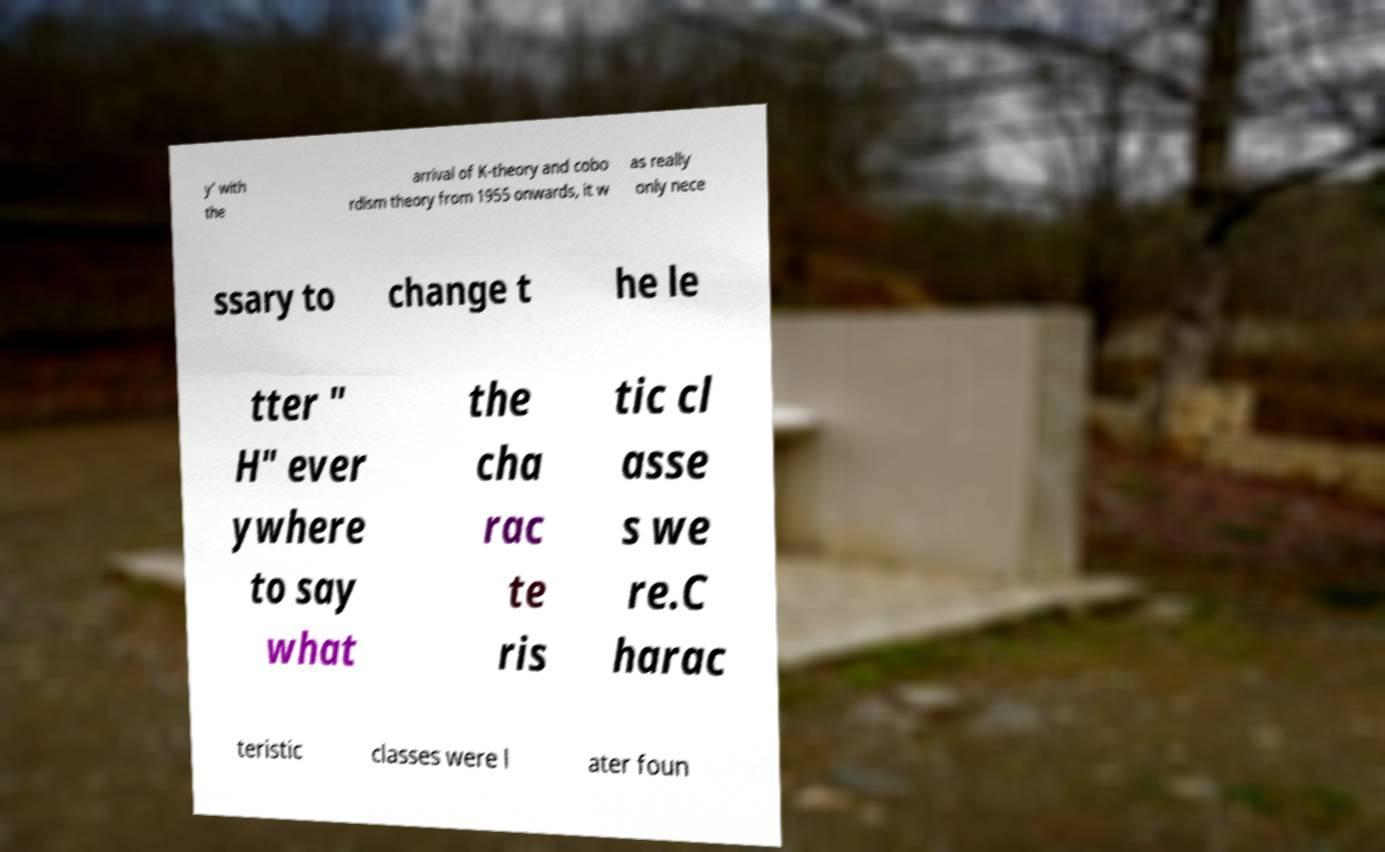Can you accurately transcribe the text from the provided image for me? y' with the arrival of K-theory and cobo rdism theory from 1955 onwards, it w as really only nece ssary to change t he le tter " H" ever ywhere to say what the cha rac te ris tic cl asse s we re.C harac teristic classes were l ater foun 